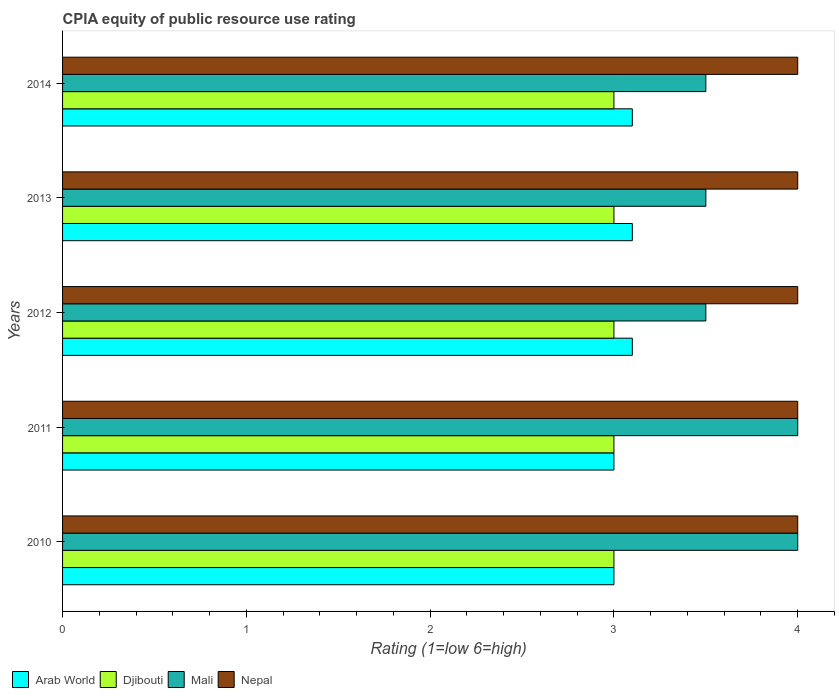How many groups of bars are there?
Make the answer very short. 5. How many bars are there on the 5th tick from the top?
Make the answer very short. 4. How many bars are there on the 3rd tick from the bottom?
Offer a terse response. 4. In how many cases, is the number of bars for a given year not equal to the number of legend labels?
Your response must be concise. 0. Across all years, what is the minimum CPIA rating in Mali?
Keep it short and to the point. 3.5. In which year was the CPIA rating in Mali minimum?
Keep it short and to the point. 2012. What is the total CPIA rating in Nepal in the graph?
Offer a very short reply. 20. What is the difference between the CPIA rating in Arab World in 2014 and the CPIA rating in Djibouti in 2013?
Provide a succinct answer. 0.1. In the year 2014, what is the difference between the CPIA rating in Mali and CPIA rating in Arab World?
Your response must be concise. 0.4. In how many years, is the CPIA rating in Arab World greater than 1.4 ?
Keep it short and to the point. 5. What is the ratio of the CPIA rating in Djibouti in 2011 to that in 2012?
Provide a succinct answer. 1. Is the difference between the CPIA rating in Mali in 2012 and 2014 greater than the difference between the CPIA rating in Arab World in 2012 and 2014?
Your response must be concise. No. What is the difference between the highest and the lowest CPIA rating in Arab World?
Your answer should be very brief. 0.1. In how many years, is the CPIA rating in Nepal greater than the average CPIA rating in Nepal taken over all years?
Offer a very short reply. 0. Is the sum of the CPIA rating in Nepal in 2012 and 2013 greater than the maximum CPIA rating in Mali across all years?
Give a very brief answer. Yes. What does the 4th bar from the top in 2014 represents?
Keep it short and to the point. Arab World. What does the 4th bar from the bottom in 2011 represents?
Ensure brevity in your answer.  Nepal. How many years are there in the graph?
Offer a very short reply. 5. Are the values on the major ticks of X-axis written in scientific E-notation?
Provide a succinct answer. No. How many legend labels are there?
Your response must be concise. 4. How are the legend labels stacked?
Offer a very short reply. Horizontal. What is the title of the graph?
Your response must be concise. CPIA equity of public resource use rating. What is the label or title of the X-axis?
Offer a terse response. Rating (1=low 6=high). What is the label or title of the Y-axis?
Your response must be concise. Years. What is the Rating (1=low 6=high) of Mali in 2010?
Provide a short and direct response. 4. What is the Rating (1=low 6=high) in Nepal in 2010?
Give a very brief answer. 4. What is the Rating (1=low 6=high) in Arab World in 2011?
Ensure brevity in your answer.  3. What is the Rating (1=low 6=high) of Mali in 2011?
Your answer should be very brief. 4. What is the Rating (1=low 6=high) of Nepal in 2011?
Make the answer very short. 4. What is the Rating (1=low 6=high) of Djibouti in 2012?
Provide a short and direct response. 3. What is the Rating (1=low 6=high) of Mali in 2012?
Offer a terse response. 3.5. What is the Rating (1=low 6=high) of Arab World in 2013?
Provide a succinct answer. 3.1. What is the Rating (1=low 6=high) in Djibouti in 2013?
Keep it short and to the point. 3. What is the Rating (1=low 6=high) in Mali in 2013?
Offer a very short reply. 3.5. What is the Rating (1=low 6=high) in Nepal in 2013?
Give a very brief answer. 4. What is the Rating (1=low 6=high) in Arab World in 2014?
Your answer should be very brief. 3.1. Across all years, what is the maximum Rating (1=low 6=high) in Djibouti?
Your answer should be compact. 3. Across all years, what is the maximum Rating (1=low 6=high) in Nepal?
Ensure brevity in your answer.  4. Across all years, what is the minimum Rating (1=low 6=high) in Djibouti?
Offer a very short reply. 3. Across all years, what is the minimum Rating (1=low 6=high) in Mali?
Your response must be concise. 3.5. Across all years, what is the minimum Rating (1=low 6=high) in Nepal?
Offer a very short reply. 4. What is the total Rating (1=low 6=high) in Djibouti in the graph?
Offer a terse response. 15. What is the total Rating (1=low 6=high) in Mali in the graph?
Your response must be concise. 18.5. What is the difference between the Rating (1=low 6=high) in Arab World in 2010 and that in 2011?
Offer a terse response. 0. What is the difference between the Rating (1=low 6=high) of Djibouti in 2010 and that in 2011?
Offer a very short reply. 0. What is the difference between the Rating (1=low 6=high) in Mali in 2010 and that in 2011?
Give a very brief answer. 0. What is the difference between the Rating (1=low 6=high) of Mali in 2010 and that in 2012?
Make the answer very short. 0.5. What is the difference between the Rating (1=low 6=high) of Arab World in 2010 and that in 2013?
Your response must be concise. -0.1. What is the difference between the Rating (1=low 6=high) in Nepal in 2010 and that in 2013?
Provide a short and direct response. 0. What is the difference between the Rating (1=low 6=high) of Arab World in 2010 and that in 2014?
Make the answer very short. -0.1. What is the difference between the Rating (1=low 6=high) in Djibouti in 2010 and that in 2014?
Offer a terse response. 0. What is the difference between the Rating (1=low 6=high) in Mali in 2010 and that in 2014?
Give a very brief answer. 0.5. What is the difference between the Rating (1=low 6=high) of Nepal in 2010 and that in 2014?
Offer a very short reply. 0. What is the difference between the Rating (1=low 6=high) in Arab World in 2011 and that in 2012?
Give a very brief answer. -0.1. What is the difference between the Rating (1=low 6=high) of Nepal in 2011 and that in 2012?
Give a very brief answer. 0. What is the difference between the Rating (1=low 6=high) in Mali in 2011 and that in 2013?
Offer a very short reply. 0.5. What is the difference between the Rating (1=low 6=high) in Nepal in 2011 and that in 2013?
Ensure brevity in your answer.  0. What is the difference between the Rating (1=low 6=high) of Arab World in 2011 and that in 2014?
Keep it short and to the point. -0.1. What is the difference between the Rating (1=low 6=high) of Djibouti in 2012 and that in 2013?
Provide a short and direct response. 0. What is the difference between the Rating (1=low 6=high) of Nepal in 2012 and that in 2013?
Your response must be concise. 0. What is the difference between the Rating (1=low 6=high) of Djibouti in 2013 and that in 2014?
Your response must be concise. 0. What is the difference between the Rating (1=low 6=high) in Arab World in 2010 and the Rating (1=low 6=high) in Djibouti in 2011?
Provide a short and direct response. 0. What is the difference between the Rating (1=low 6=high) in Arab World in 2010 and the Rating (1=low 6=high) in Djibouti in 2012?
Your answer should be very brief. 0. What is the difference between the Rating (1=low 6=high) in Djibouti in 2010 and the Rating (1=low 6=high) in Mali in 2013?
Ensure brevity in your answer.  -0.5. What is the difference between the Rating (1=low 6=high) of Mali in 2010 and the Rating (1=low 6=high) of Nepal in 2013?
Keep it short and to the point. 0. What is the difference between the Rating (1=low 6=high) of Arab World in 2010 and the Rating (1=low 6=high) of Djibouti in 2014?
Your answer should be compact. 0. What is the difference between the Rating (1=low 6=high) of Arab World in 2010 and the Rating (1=low 6=high) of Mali in 2014?
Your answer should be compact. -0.5. What is the difference between the Rating (1=low 6=high) of Arab World in 2010 and the Rating (1=low 6=high) of Nepal in 2014?
Offer a very short reply. -1. What is the difference between the Rating (1=low 6=high) of Arab World in 2011 and the Rating (1=low 6=high) of Mali in 2012?
Keep it short and to the point. -0.5. What is the difference between the Rating (1=low 6=high) of Arab World in 2011 and the Rating (1=low 6=high) of Nepal in 2012?
Ensure brevity in your answer.  -1. What is the difference between the Rating (1=low 6=high) in Djibouti in 2011 and the Rating (1=low 6=high) in Mali in 2012?
Make the answer very short. -0.5. What is the difference between the Rating (1=low 6=high) of Arab World in 2011 and the Rating (1=low 6=high) of Mali in 2013?
Offer a very short reply. -0.5. What is the difference between the Rating (1=low 6=high) in Arab World in 2011 and the Rating (1=low 6=high) in Nepal in 2013?
Make the answer very short. -1. What is the difference between the Rating (1=low 6=high) of Arab World in 2011 and the Rating (1=low 6=high) of Mali in 2014?
Keep it short and to the point. -0.5. What is the difference between the Rating (1=low 6=high) of Arab World in 2011 and the Rating (1=low 6=high) of Nepal in 2014?
Give a very brief answer. -1. What is the difference between the Rating (1=low 6=high) in Djibouti in 2011 and the Rating (1=low 6=high) in Mali in 2014?
Offer a terse response. -0.5. What is the difference between the Rating (1=low 6=high) in Djibouti in 2011 and the Rating (1=low 6=high) in Nepal in 2014?
Offer a very short reply. -1. What is the difference between the Rating (1=low 6=high) in Mali in 2011 and the Rating (1=low 6=high) in Nepal in 2014?
Your answer should be very brief. 0. What is the difference between the Rating (1=low 6=high) in Arab World in 2012 and the Rating (1=low 6=high) in Mali in 2013?
Give a very brief answer. -0.4. What is the difference between the Rating (1=low 6=high) in Arab World in 2012 and the Rating (1=low 6=high) in Nepal in 2013?
Give a very brief answer. -0.9. What is the difference between the Rating (1=low 6=high) in Djibouti in 2012 and the Rating (1=low 6=high) in Mali in 2013?
Provide a short and direct response. -0.5. What is the difference between the Rating (1=low 6=high) in Djibouti in 2012 and the Rating (1=low 6=high) in Nepal in 2013?
Offer a very short reply. -1. What is the difference between the Rating (1=low 6=high) in Mali in 2012 and the Rating (1=low 6=high) in Nepal in 2013?
Provide a succinct answer. -0.5. What is the difference between the Rating (1=low 6=high) of Arab World in 2012 and the Rating (1=low 6=high) of Mali in 2014?
Your answer should be compact. -0.4. What is the difference between the Rating (1=low 6=high) in Arab World in 2012 and the Rating (1=low 6=high) in Nepal in 2014?
Your response must be concise. -0.9. What is the difference between the Rating (1=low 6=high) in Djibouti in 2012 and the Rating (1=low 6=high) in Mali in 2014?
Give a very brief answer. -0.5. What is the difference between the Rating (1=low 6=high) of Djibouti in 2012 and the Rating (1=low 6=high) of Nepal in 2014?
Give a very brief answer. -1. What is the difference between the Rating (1=low 6=high) in Arab World in 2013 and the Rating (1=low 6=high) in Nepal in 2014?
Offer a terse response. -0.9. What is the difference between the Rating (1=low 6=high) of Djibouti in 2013 and the Rating (1=low 6=high) of Nepal in 2014?
Offer a very short reply. -1. What is the difference between the Rating (1=low 6=high) in Mali in 2013 and the Rating (1=low 6=high) in Nepal in 2014?
Ensure brevity in your answer.  -0.5. What is the average Rating (1=low 6=high) in Arab World per year?
Keep it short and to the point. 3.06. What is the average Rating (1=low 6=high) of Djibouti per year?
Your response must be concise. 3. What is the average Rating (1=low 6=high) of Mali per year?
Your answer should be very brief. 3.7. In the year 2010, what is the difference between the Rating (1=low 6=high) of Arab World and Rating (1=low 6=high) of Djibouti?
Make the answer very short. 0. In the year 2010, what is the difference between the Rating (1=low 6=high) of Djibouti and Rating (1=low 6=high) of Mali?
Keep it short and to the point. -1. In the year 2010, what is the difference between the Rating (1=low 6=high) in Djibouti and Rating (1=low 6=high) in Nepal?
Give a very brief answer. -1. In the year 2010, what is the difference between the Rating (1=low 6=high) in Mali and Rating (1=low 6=high) in Nepal?
Your answer should be very brief. 0. In the year 2011, what is the difference between the Rating (1=low 6=high) of Arab World and Rating (1=low 6=high) of Djibouti?
Your response must be concise. 0. In the year 2011, what is the difference between the Rating (1=low 6=high) in Djibouti and Rating (1=low 6=high) in Mali?
Ensure brevity in your answer.  -1. In the year 2012, what is the difference between the Rating (1=low 6=high) in Djibouti and Rating (1=low 6=high) in Mali?
Your answer should be very brief. -0.5. In the year 2012, what is the difference between the Rating (1=low 6=high) of Djibouti and Rating (1=low 6=high) of Nepal?
Offer a terse response. -1. In the year 2013, what is the difference between the Rating (1=low 6=high) in Arab World and Rating (1=low 6=high) in Mali?
Your answer should be very brief. -0.4. In the year 2013, what is the difference between the Rating (1=low 6=high) in Arab World and Rating (1=low 6=high) in Nepal?
Keep it short and to the point. -0.9. In the year 2013, what is the difference between the Rating (1=low 6=high) of Mali and Rating (1=low 6=high) of Nepal?
Keep it short and to the point. -0.5. In the year 2014, what is the difference between the Rating (1=low 6=high) of Arab World and Rating (1=low 6=high) of Djibouti?
Provide a short and direct response. 0.1. In the year 2014, what is the difference between the Rating (1=low 6=high) in Arab World and Rating (1=low 6=high) in Nepal?
Make the answer very short. -0.9. In the year 2014, what is the difference between the Rating (1=low 6=high) of Mali and Rating (1=low 6=high) of Nepal?
Offer a very short reply. -0.5. What is the ratio of the Rating (1=low 6=high) of Arab World in 2010 to that in 2012?
Offer a terse response. 0.97. What is the ratio of the Rating (1=low 6=high) of Djibouti in 2010 to that in 2012?
Your response must be concise. 1. What is the ratio of the Rating (1=low 6=high) of Nepal in 2010 to that in 2012?
Keep it short and to the point. 1. What is the ratio of the Rating (1=low 6=high) in Djibouti in 2010 to that in 2013?
Make the answer very short. 1. What is the ratio of the Rating (1=low 6=high) in Mali in 2010 to that in 2013?
Provide a succinct answer. 1.14. What is the ratio of the Rating (1=low 6=high) in Arab World in 2010 to that in 2014?
Your answer should be compact. 0.97. What is the ratio of the Rating (1=low 6=high) of Djibouti in 2010 to that in 2014?
Offer a terse response. 1. What is the ratio of the Rating (1=low 6=high) in Arab World in 2011 to that in 2012?
Provide a succinct answer. 0.97. What is the ratio of the Rating (1=low 6=high) of Mali in 2011 to that in 2012?
Give a very brief answer. 1.14. What is the ratio of the Rating (1=low 6=high) of Nepal in 2011 to that in 2012?
Provide a succinct answer. 1. What is the ratio of the Rating (1=low 6=high) of Djibouti in 2011 to that in 2013?
Offer a terse response. 1. What is the ratio of the Rating (1=low 6=high) of Arab World in 2012 to that in 2013?
Give a very brief answer. 1. What is the ratio of the Rating (1=low 6=high) in Arab World in 2012 to that in 2014?
Keep it short and to the point. 1. What is the ratio of the Rating (1=low 6=high) of Djibouti in 2012 to that in 2014?
Your answer should be compact. 1. What is the ratio of the Rating (1=low 6=high) of Nepal in 2012 to that in 2014?
Ensure brevity in your answer.  1. What is the ratio of the Rating (1=low 6=high) in Arab World in 2013 to that in 2014?
Ensure brevity in your answer.  1. What is the ratio of the Rating (1=low 6=high) of Mali in 2013 to that in 2014?
Make the answer very short. 1. What is the difference between the highest and the second highest Rating (1=low 6=high) of Djibouti?
Offer a terse response. 0. What is the difference between the highest and the second highest Rating (1=low 6=high) in Mali?
Your answer should be compact. 0. What is the difference between the highest and the lowest Rating (1=low 6=high) of Arab World?
Your answer should be very brief. 0.1. What is the difference between the highest and the lowest Rating (1=low 6=high) of Mali?
Give a very brief answer. 0.5. What is the difference between the highest and the lowest Rating (1=low 6=high) of Nepal?
Your response must be concise. 0. 